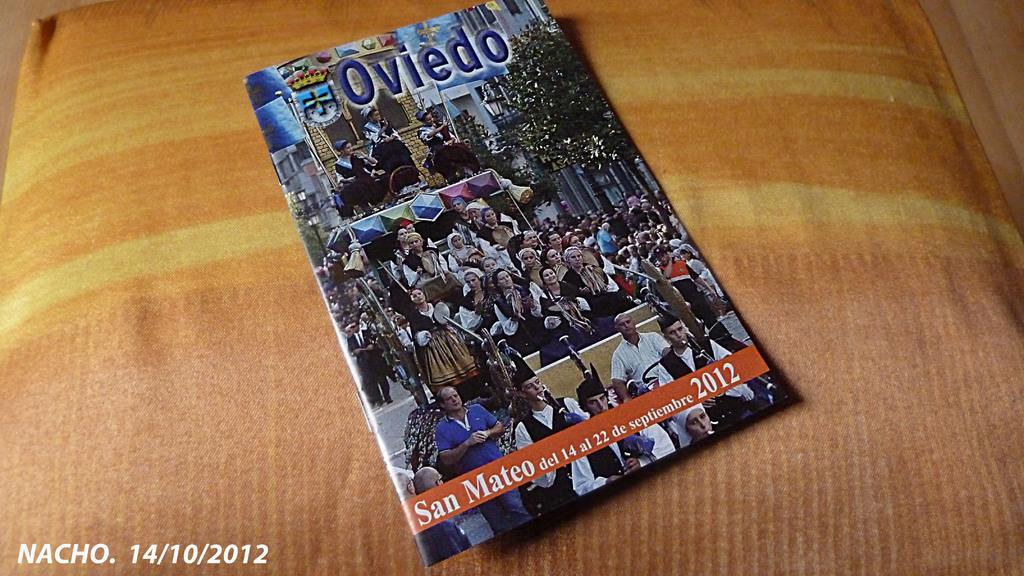<image>
Give a short and clear explanation of the subsequent image. A programme from a musical concert in San Mateo in 2012 lies on a cushion. 